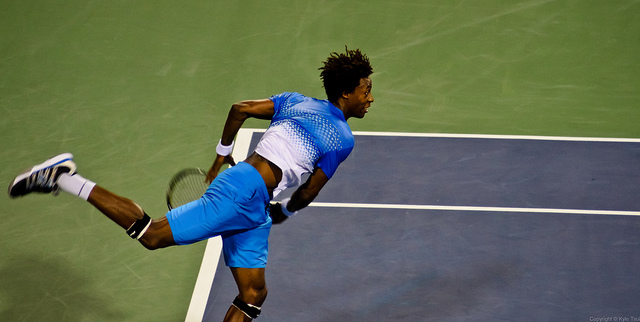<image>Is the man a tennis professional? I don't know if the man is a tennis professional. Is the man a tennis professional? I don't know if the man is a tennis professional. It is possible that he is. 